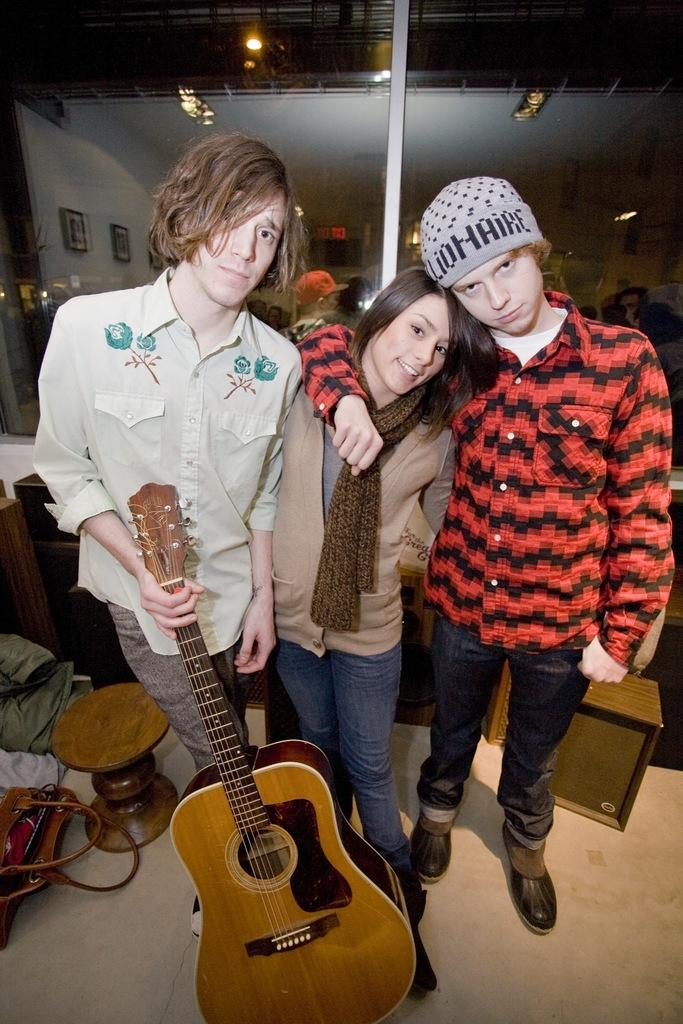How many people are in the image? There are three people in the image. Can you describe the position of the man on the left side of the image? The man is standing on the left side of the image. What is the man holding in the image? The man is holding a guitar. How much does the cobweb cost in the image? There is no cobweb present in the image, so it cannot be determined how much it would cost. 